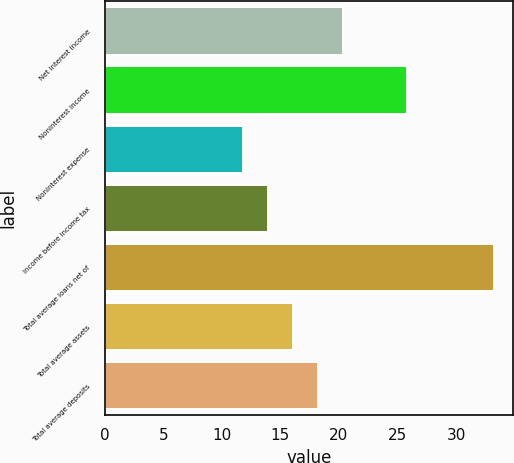<chart> <loc_0><loc_0><loc_500><loc_500><bar_chart><fcel>Net interest income<fcel>Noninterest income<fcel>Noninterest expense<fcel>Income before income tax<fcel>Total average loans net of<fcel>Total average assets<fcel>Total average deposits<nl><fcel>20.36<fcel>25.8<fcel>11.8<fcel>13.94<fcel>33.2<fcel>16.08<fcel>18.22<nl></chart> 